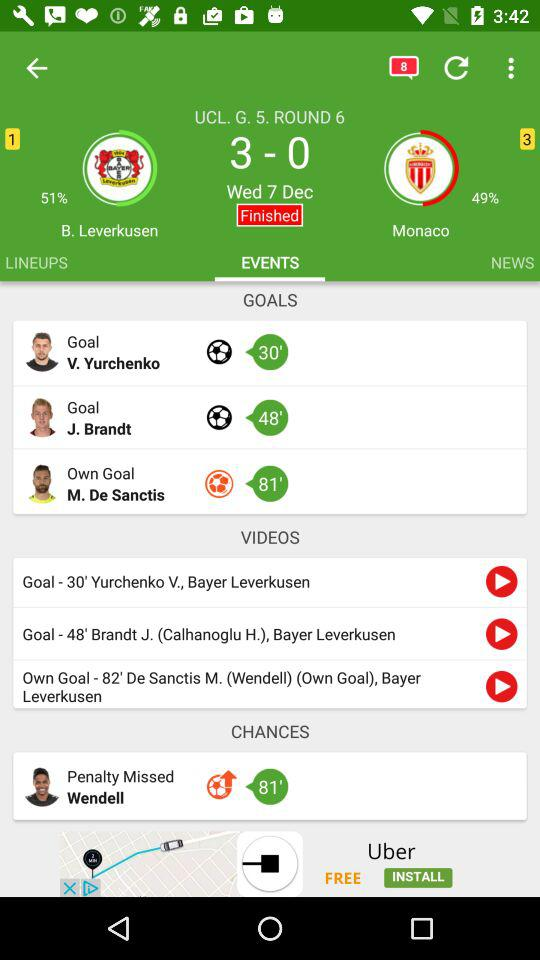What is the percentage of "Monaco"? The percentage of "Monaco" is 49%. 